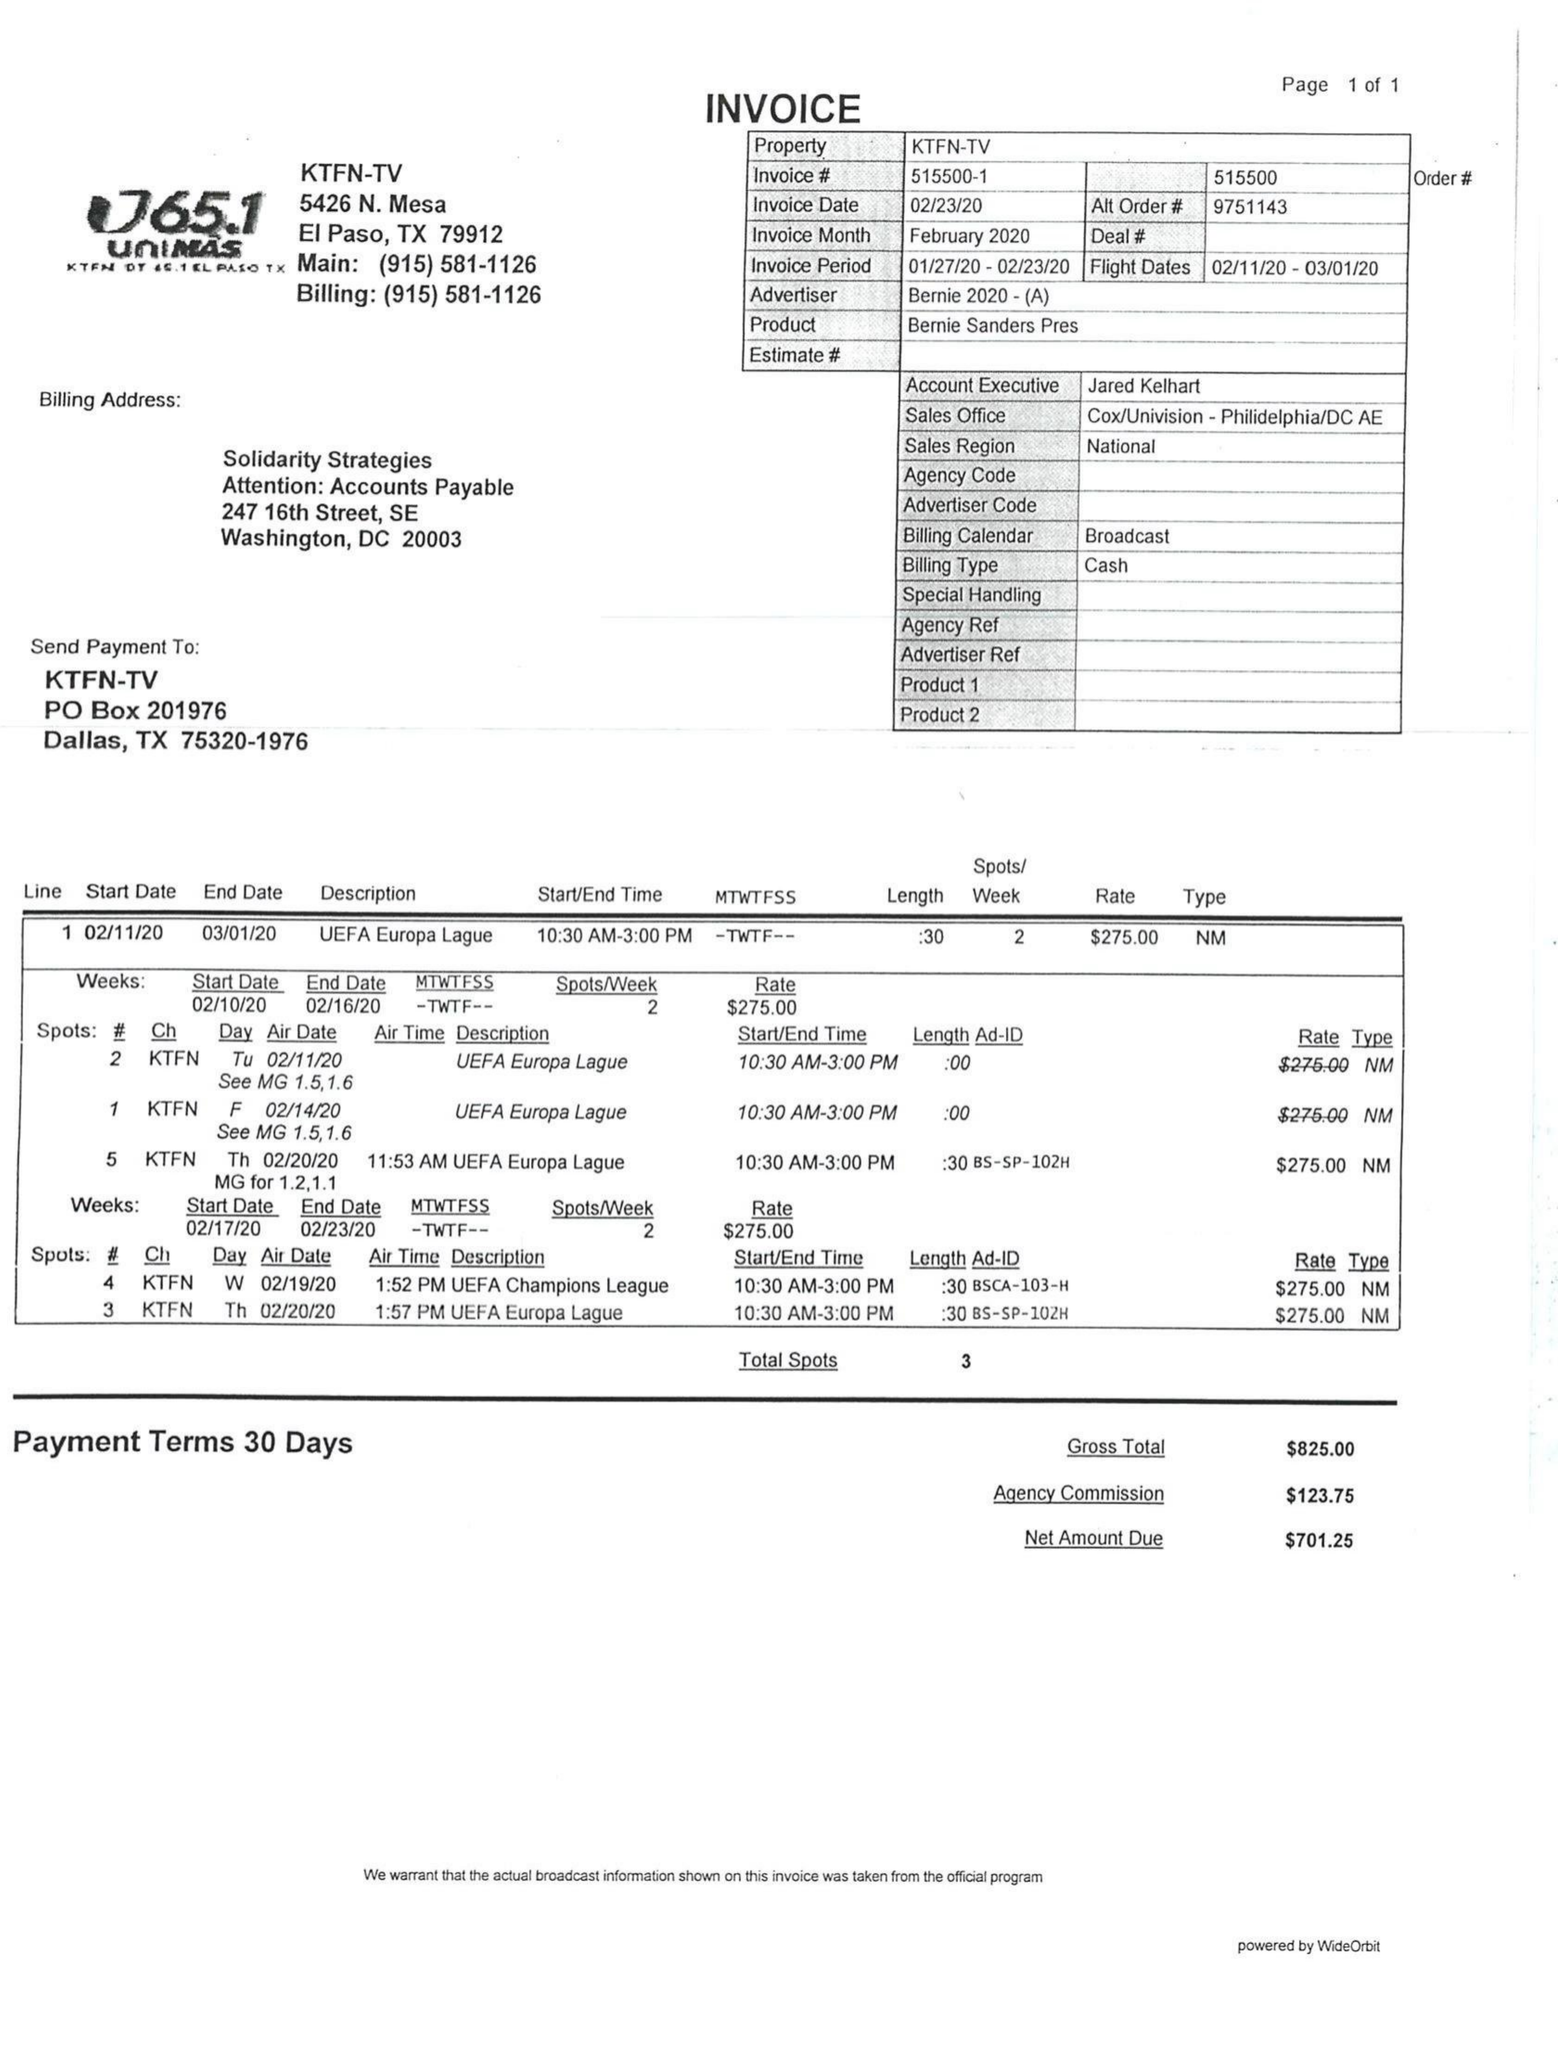What is the value for the contract_num?
Answer the question using a single word or phrase. 515500 